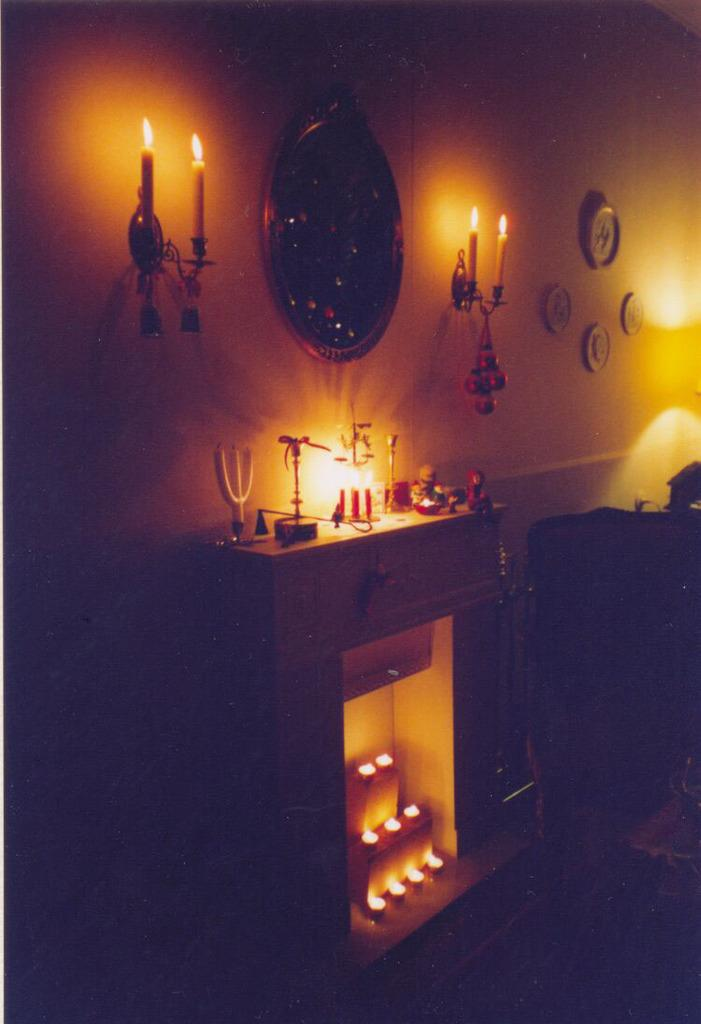What types of objects can be seen in the image? There are candies and toys in the image. Where are the candies and toys located? The candies and toys are on a cupboard. What can be seen on the wall in the background of the image? There are frames and candles on the wall in the background of the image. How many babies are crawling on the floor in the image? There are no babies present in the image; it features candies, toys, a cupboard, frames, and candles on the wall. 